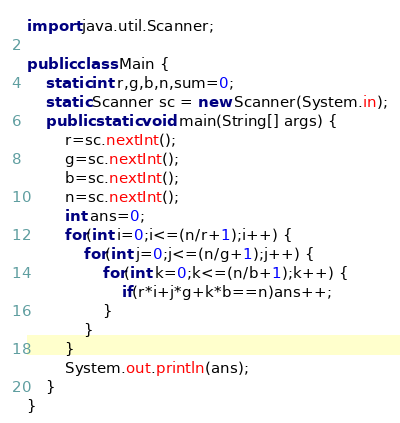Convert code to text. <code><loc_0><loc_0><loc_500><loc_500><_Java_>import java.util.Scanner;

public class Main {
	static int r,g,b,n,sum=0;
	static Scanner sc = new Scanner(System.in);
	public static void main(String[] args) {
		r=sc.nextInt();
		g=sc.nextInt();
		b=sc.nextInt();
		n=sc.nextInt();
		int ans=0;
		for(int i=0;i<=(n/r+1);i++) {
			for(int j=0;j<=(n/g+1);j++) {
				for(int k=0;k<=(n/b+1);k++) {
					if(r*i+j*g+k*b==n)ans++;
				}
			}
		}
		System.out.println(ans);
	}
}
</code> 